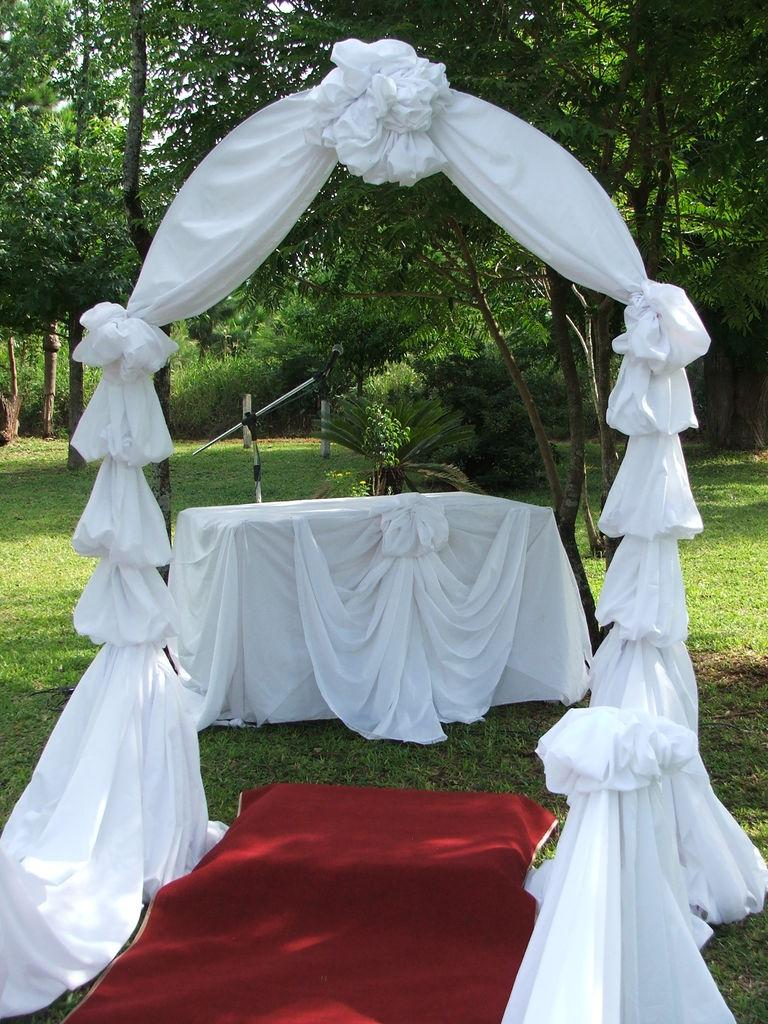What type of floor covering is present in the image? There is a carpet in the image. What decorative item can be seen hanging in the image? There is a banner in the image. What piece of furniture is visible in the image? There is a table in the image. What type of vegetation is visible in the background of the image? There are plants, trees, and grass visible in the background of the image. What type of glue is being used to hold the lunch together in the image? There is no lunch present in the image, and therefore no glue is being used to hold it together. How many trees are visible in the image? The provided facts do not specify the exact number of trees visible in the image, but there are trees visible in the background. 